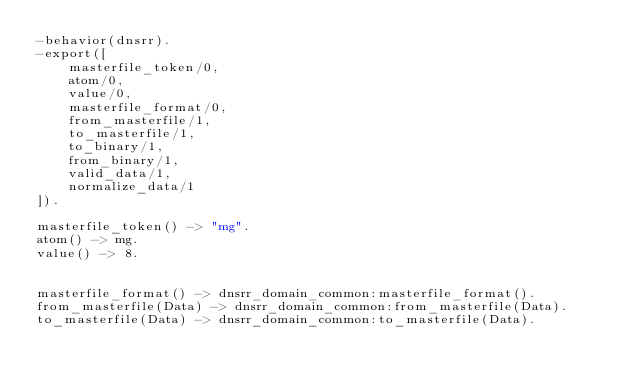Convert code to text. <code><loc_0><loc_0><loc_500><loc_500><_Erlang_>-behavior(dnsrr).
-export([
    masterfile_token/0,
    atom/0,
    value/0,
    masterfile_format/0,
    from_masterfile/1,
    to_masterfile/1,
    to_binary/1,
    from_binary/1,
    valid_data/1,
    normalize_data/1
]).

masterfile_token() -> "mg".
atom() -> mg.
value() -> 8.


masterfile_format() -> dnsrr_domain_common:masterfile_format().
from_masterfile(Data) -> dnsrr_domain_common:from_masterfile(Data).
to_masterfile(Data) -> dnsrr_domain_common:to_masterfile(Data).</code> 